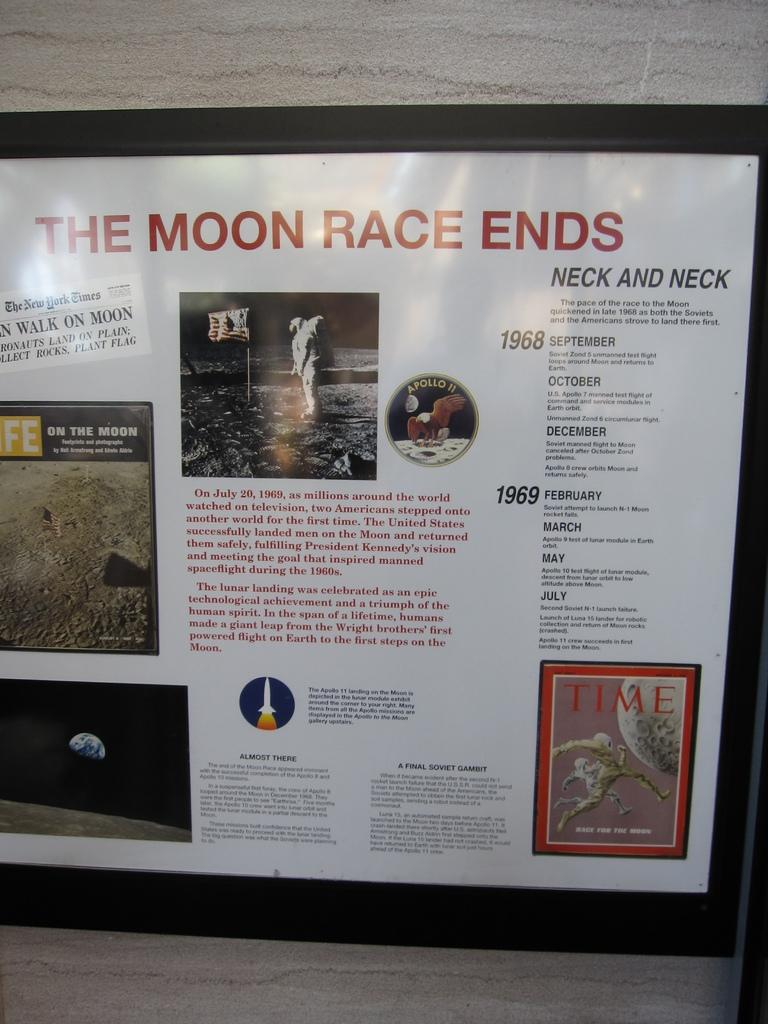<image>
Render a clear and concise summary of the photo. A picture and timeline for the moon race that started in 1968. 